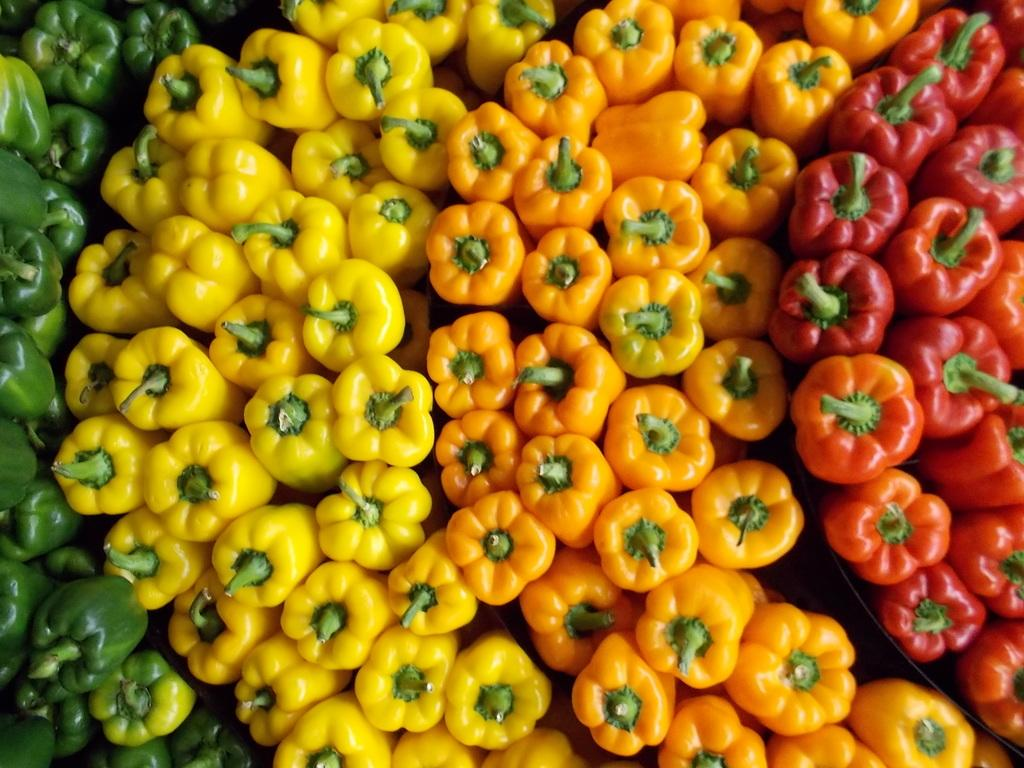What type of vegetables are in the image? There are capsicums in the image. What colors are the capsicums in the image? The capsicums are in green, yellow, orange, and red colors. How are the capsicums arranged in the image? The capsicums are arranged in the image. What type of plane can be seen flying over the capsicums in the image? There is no plane visible in the image; it only features capsicums arranged in various colors. 